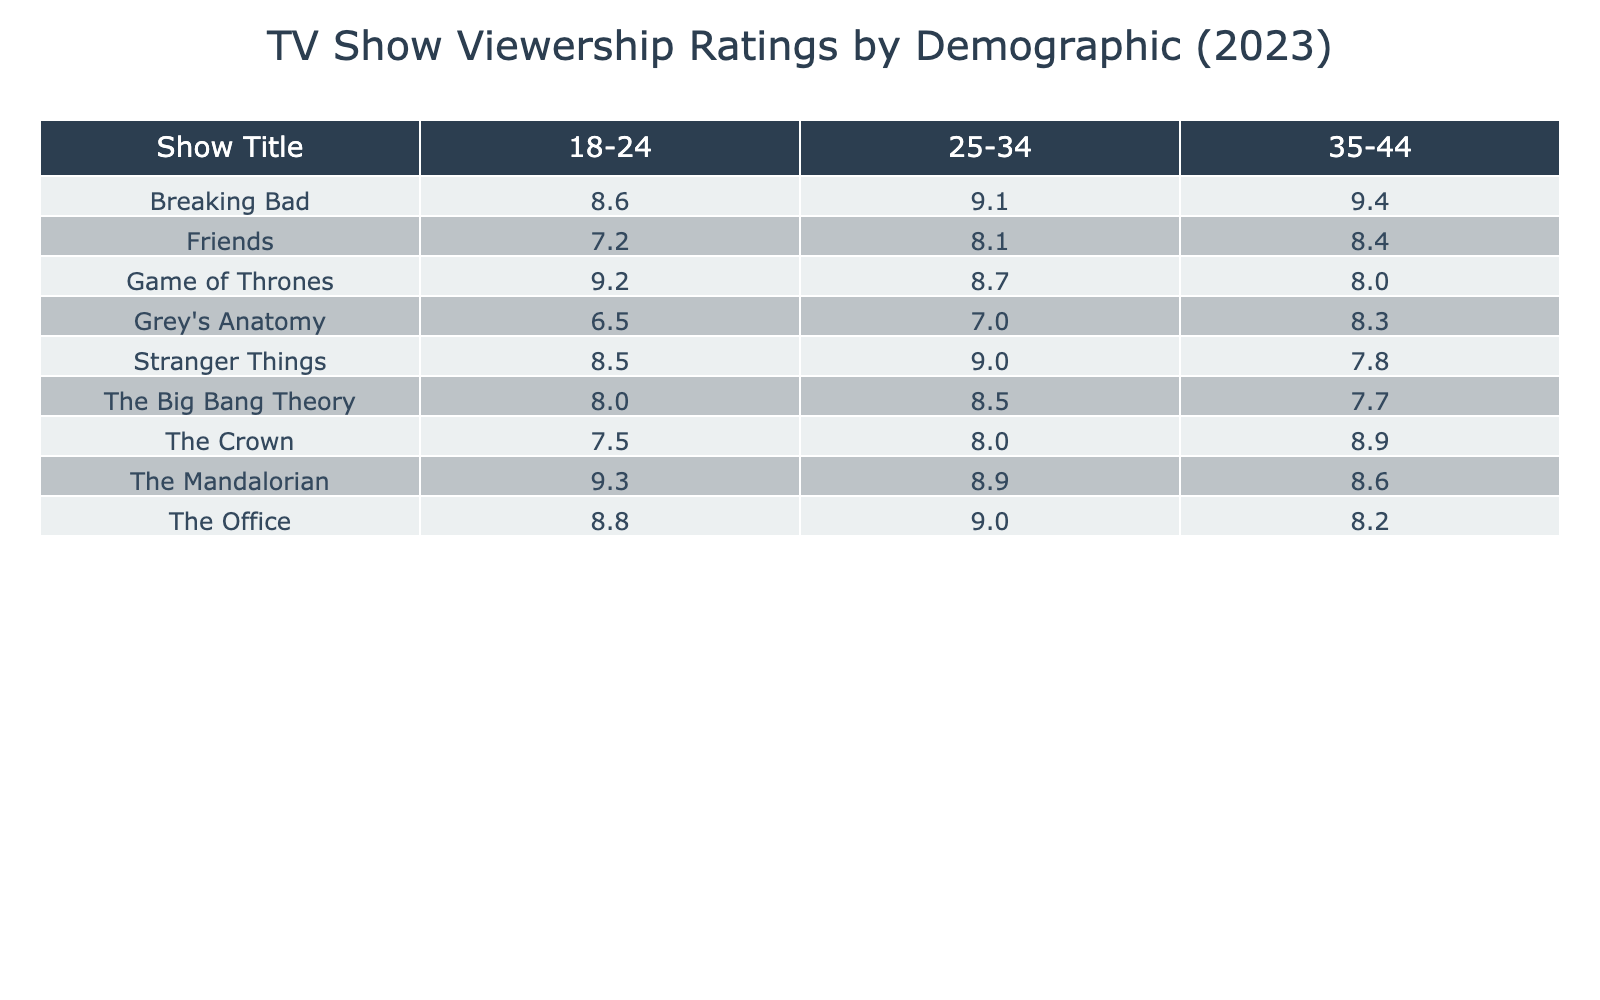What is the viewership rating of "Breaking Bad" in the 25-34 demographic? According to the table, the viewership rating for "Breaking Bad" in the demographic of 25-34 is listed as 9.1.
Answer: 9.1 Which show has the highest viewership rating among the 18-24 demographic? "The Mandalorian" has the highest viewership rating in the 18-24 demographic with a rating of 9.3, as shown in the table.
Answer: 9.3 Is the viewership rating of "Grey's Anatomy" higher in the 35-44 demographic than in the 18-24 demographic? The viewership rating for "Grey's Anatomy" in the 35-44 demographic is 8.3, while the rating in the 18-24 demographic is 6.5. Since 8.3 is greater than 6.5, the statement is true.
Answer: Yes What is the average viewership rating for "Friends"? The ratings for "Friends" across the three demographics are 7.2, 8.1, and 8.4. Adding these yields 23.7, and dividing by 3 gives an average of 7.9.
Answer: 7.9 Which demographic has the lowest viewership rating for "The Big Bang Theory"? In the table, the viewership rating for "The Big Bang Theory" in the 35-44 demographic is 7.7, which is lower than the ratings for the other demographics, confirming it has the lowest rating.
Answer: 7.7 What is the difference in viewership ratings between "Game of Thrones" in the 18-24 and 35-44 demographics? The viewership rating for "Game of Thrones" in the 18-24 demographic is 9.2, while in the 35-44 demographic it is 8.0. The difference is calculated as 9.2 - 8.0 = 1.2.
Answer: 1.2 Which show shows the largest drop in viewership from the 25-34 demographic to the 35-44 demographic? By comparing the ratings, "Breaking Bad" drops from 9.1 (25-34) to 9.4 (35-44) = -0.3, "Stranger Things" drops -0.2, "Grey's Anatomy" drops -0.7, and "The Mandalorian" drops -0.3. "Grey's Anatomy" shows the largest drop.
Answer: "Grey's Anatomy" Which show has consistent ratings across all demographics? Analyzing the viewership ratings of each show, "Friends" has ratings of 7.2, 8.1, and 8.4, showing little fluctuation compared to others, but "The Office" is also consistent with values close together (8.8, 9.0, 8.2). Viewing their ranges, both shows are competitively consistent.
Answer: "Friends" and "The Office" 